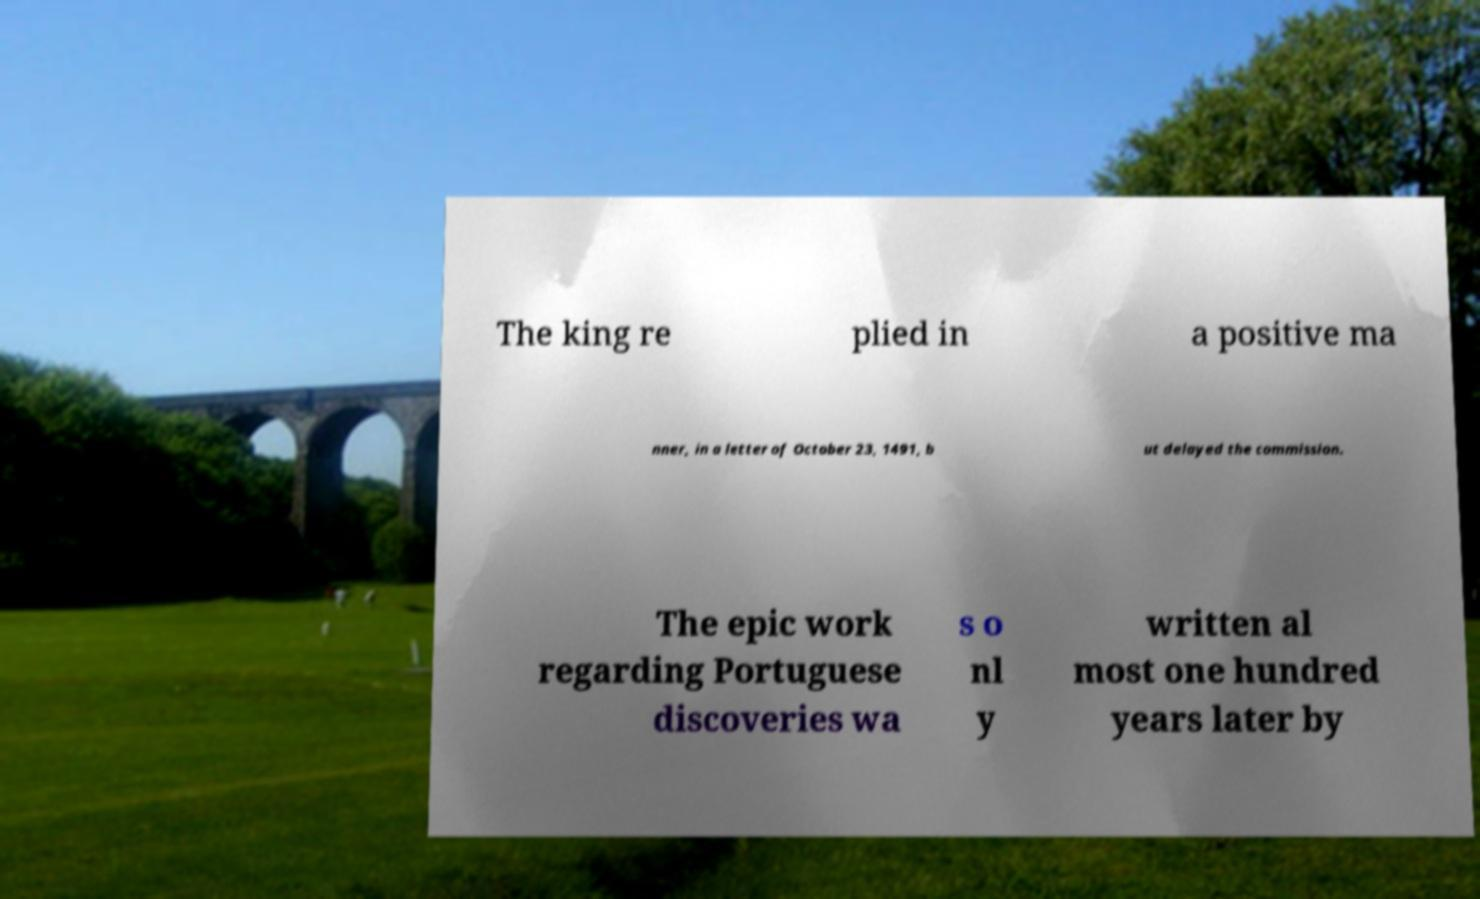Please identify and transcribe the text found in this image. The king re plied in a positive ma nner, in a letter of October 23, 1491, b ut delayed the commission. The epic work regarding Portuguese discoveries wa s o nl y written al most one hundred years later by 